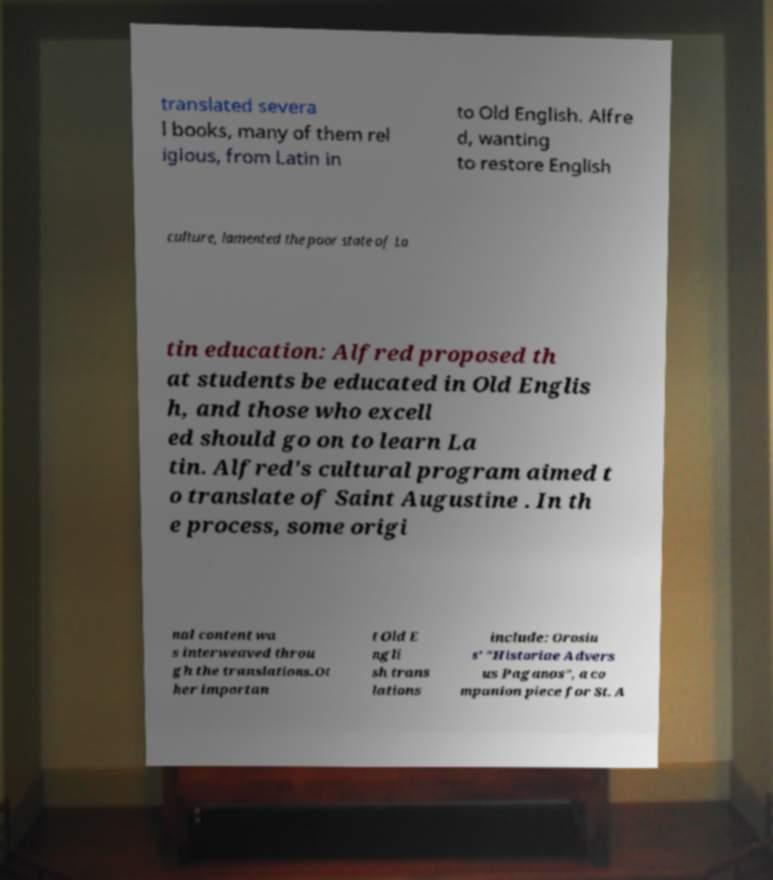Can you accurately transcribe the text from the provided image for me? translated severa l books, many of them rel igious, from Latin in to Old English. Alfre d, wanting to restore English culture, lamented the poor state of La tin education: Alfred proposed th at students be educated in Old Englis h, and those who excell ed should go on to learn La tin. Alfred's cultural program aimed t o translate of Saint Augustine . In th e process, some origi nal content wa s interweaved throu gh the translations.Ot her importan t Old E ngli sh trans lations include: Orosiu s' "Historiae Advers us Paganos", a co mpanion piece for St. A 